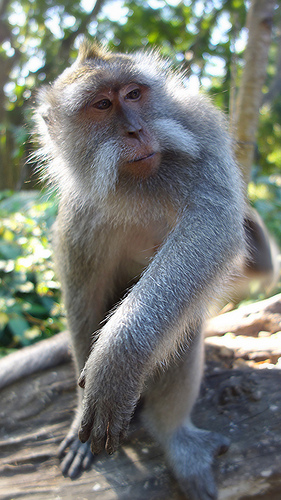<image>
Is there a monkey under the tree trunk? No. The monkey is not positioned under the tree trunk. The vertical relationship between these objects is different. 